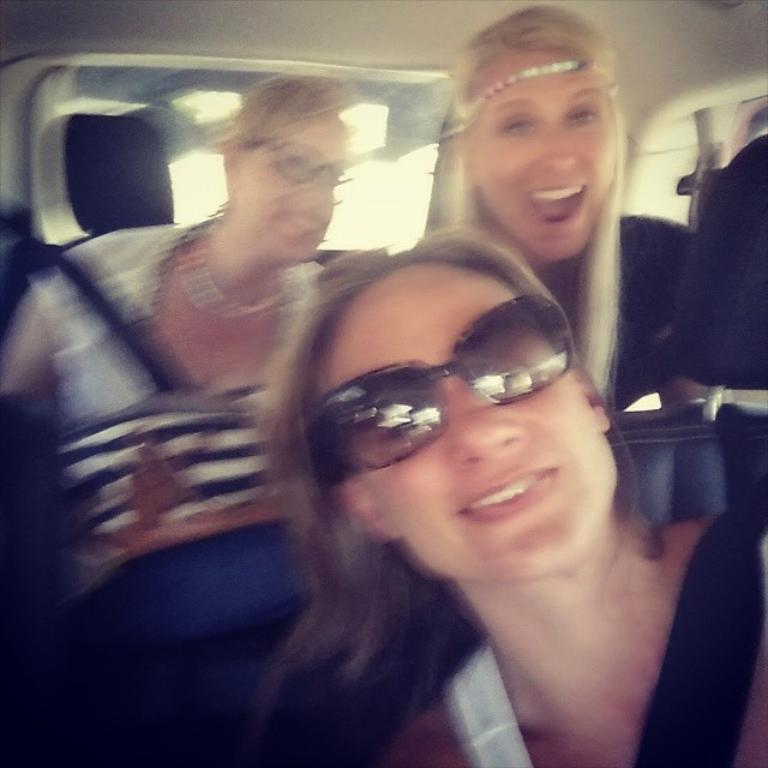Who or what can be seen in the image? There are people in the image. Can you describe the setting of the image? The image shows the inside of a vehicle. What type of turkey is being served in the vehicle? There is no turkey present in the image; it shows people inside a vehicle. 